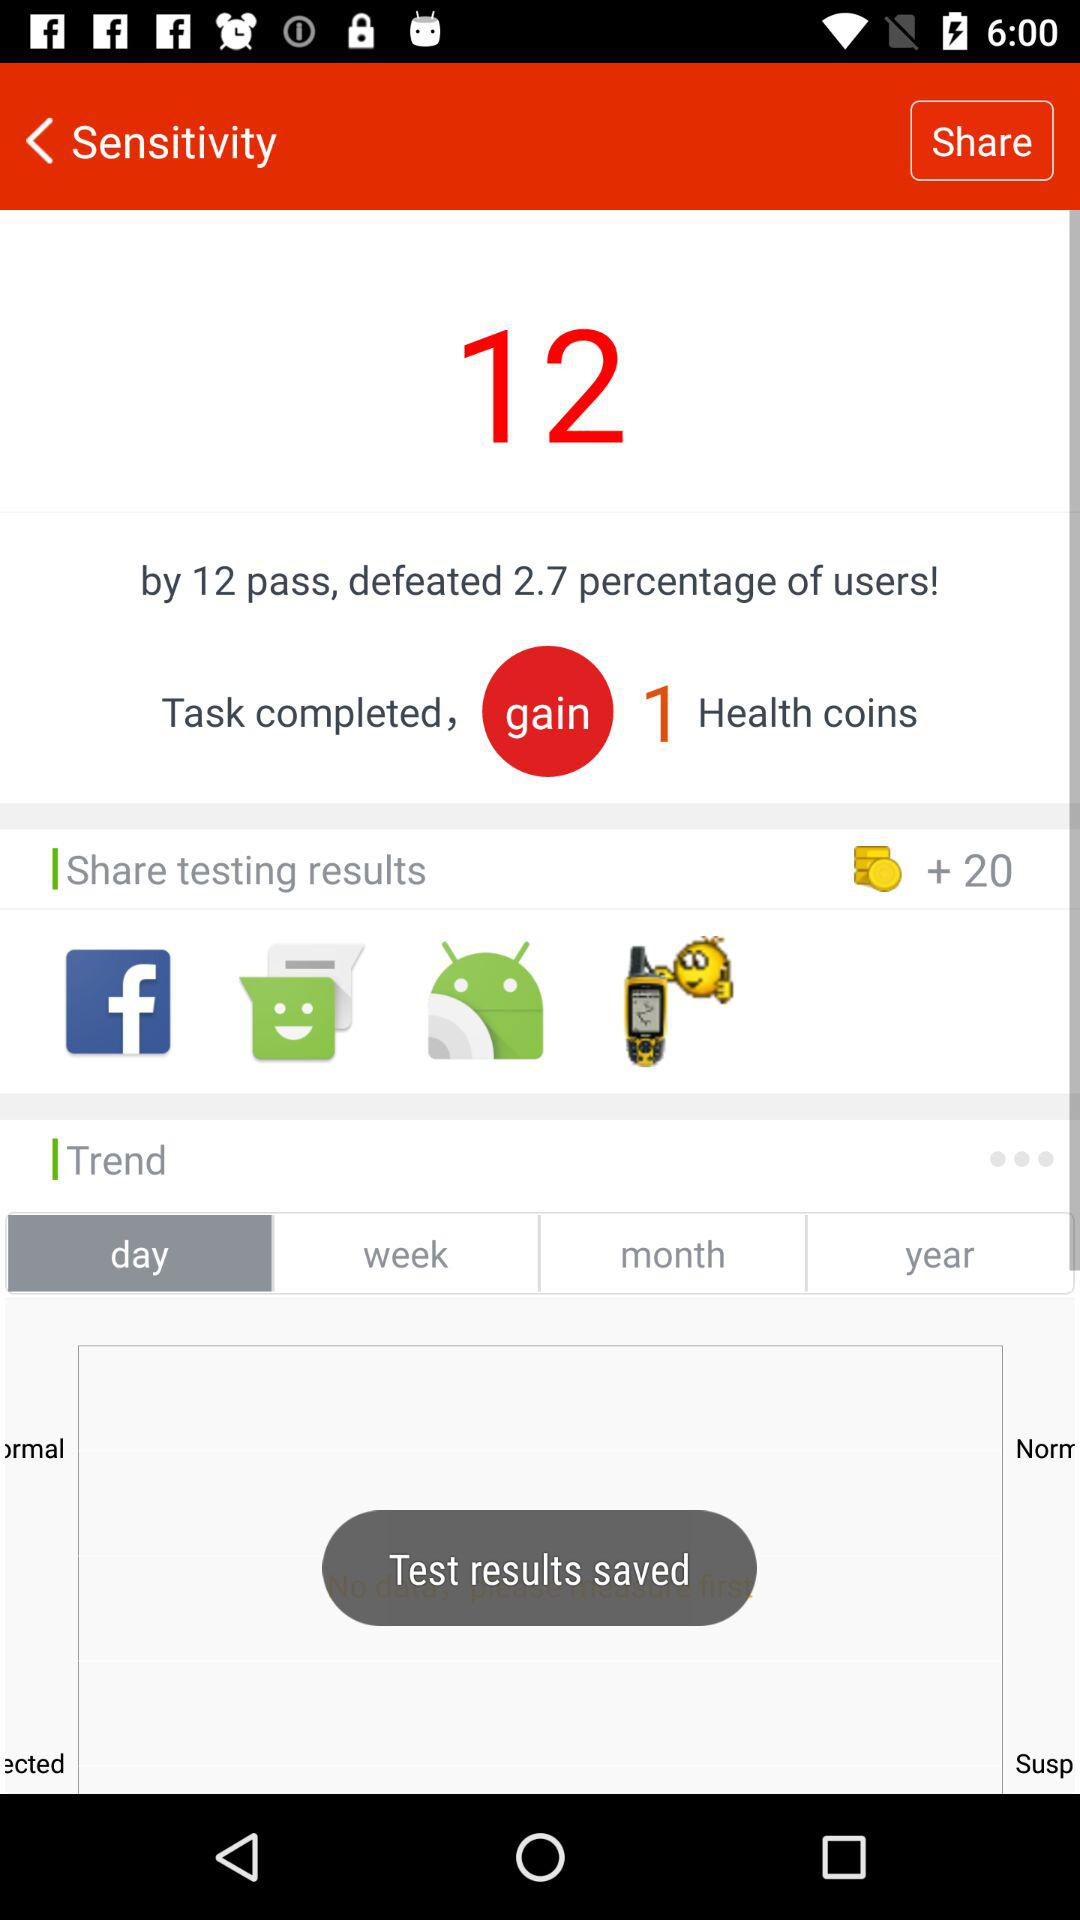How many health coins are gained? There is 1 health coin gained. 